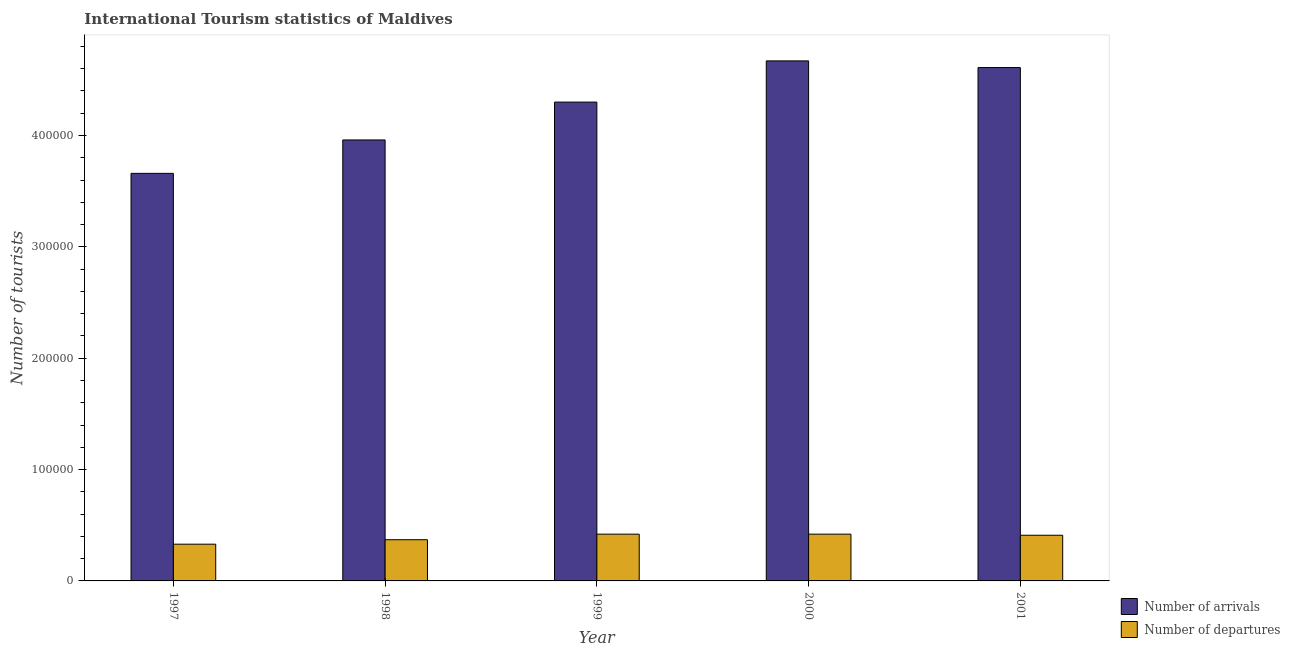How many groups of bars are there?
Offer a very short reply. 5. How many bars are there on the 4th tick from the left?
Give a very brief answer. 2. What is the label of the 2nd group of bars from the left?
Keep it short and to the point. 1998. In how many cases, is the number of bars for a given year not equal to the number of legend labels?
Your answer should be very brief. 0. What is the number of tourist departures in 1999?
Provide a succinct answer. 4.20e+04. Across all years, what is the maximum number of tourist departures?
Offer a terse response. 4.20e+04. Across all years, what is the minimum number of tourist arrivals?
Your response must be concise. 3.66e+05. In which year was the number of tourist departures maximum?
Make the answer very short. 1999. What is the total number of tourist arrivals in the graph?
Keep it short and to the point. 2.12e+06. What is the difference between the number of tourist arrivals in 1999 and that in 2001?
Provide a succinct answer. -3.10e+04. What is the difference between the number of tourist arrivals in 2001 and the number of tourist departures in 1999?
Provide a succinct answer. 3.10e+04. What is the average number of tourist departures per year?
Provide a succinct answer. 3.90e+04. What is the ratio of the number of tourist arrivals in 1999 to that in 2000?
Keep it short and to the point. 0.92. Is the number of tourist departures in 1997 less than that in 2000?
Offer a terse response. Yes. What is the difference between the highest and the lowest number of tourist departures?
Provide a succinct answer. 9000. In how many years, is the number of tourist departures greater than the average number of tourist departures taken over all years?
Your answer should be very brief. 3. What does the 1st bar from the left in 1997 represents?
Your response must be concise. Number of arrivals. What does the 1st bar from the right in 2001 represents?
Ensure brevity in your answer.  Number of departures. How many years are there in the graph?
Provide a short and direct response. 5. What is the difference between two consecutive major ticks on the Y-axis?
Keep it short and to the point. 1.00e+05. Are the values on the major ticks of Y-axis written in scientific E-notation?
Your response must be concise. No. Does the graph contain any zero values?
Provide a succinct answer. No. How many legend labels are there?
Offer a very short reply. 2. What is the title of the graph?
Your answer should be compact. International Tourism statistics of Maldives. Does "Boys" appear as one of the legend labels in the graph?
Ensure brevity in your answer.  No. What is the label or title of the Y-axis?
Keep it short and to the point. Number of tourists. What is the Number of tourists of Number of arrivals in 1997?
Your response must be concise. 3.66e+05. What is the Number of tourists in Number of departures in 1997?
Keep it short and to the point. 3.30e+04. What is the Number of tourists in Number of arrivals in 1998?
Make the answer very short. 3.96e+05. What is the Number of tourists of Number of departures in 1998?
Offer a terse response. 3.70e+04. What is the Number of tourists in Number of arrivals in 1999?
Give a very brief answer. 4.30e+05. What is the Number of tourists of Number of departures in 1999?
Your answer should be compact. 4.20e+04. What is the Number of tourists in Number of arrivals in 2000?
Ensure brevity in your answer.  4.67e+05. What is the Number of tourists of Number of departures in 2000?
Provide a short and direct response. 4.20e+04. What is the Number of tourists in Number of arrivals in 2001?
Your answer should be very brief. 4.61e+05. What is the Number of tourists of Number of departures in 2001?
Your response must be concise. 4.10e+04. Across all years, what is the maximum Number of tourists in Number of arrivals?
Provide a short and direct response. 4.67e+05. Across all years, what is the maximum Number of tourists of Number of departures?
Offer a very short reply. 4.20e+04. Across all years, what is the minimum Number of tourists in Number of arrivals?
Provide a short and direct response. 3.66e+05. Across all years, what is the minimum Number of tourists of Number of departures?
Provide a succinct answer. 3.30e+04. What is the total Number of tourists of Number of arrivals in the graph?
Offer a very short reply. 2.12e+06. What is the total Number of tourists of Number of departures in the graph?
Your answer should be very brief. 1.95e+05. What is the difference between the Number of tourists of Number of arrivals in 1997 and that in 1998?
Make the answer very short. -3.00e+04. What is the difference between the Number of tourists of Number of departures in 1997 and that in 1998?
Your response must be concise. -4000. What is the difference between the Number of tourists in Number of arrivals in 1997 and that in 1999?
Your answer should be compact. -6.40e+04. What is the difference between the Number of tourists in Number of departures in 1997 and that in 1999?
Provide a short and direct response. -9000. What is the difference between the Number of tourists of Number of arrivals in 1997 and that in 2000?
Your response must be concise. -1.01e+05. What is the difference between the Number of tourists of Number of departures in 1997 and that in 2000?
Provide a succinct answer. -9000. What is the difference between the Number of tourists in Number of arrivals in 1997 and that in 2001?
Provide a short and direct response. -9.50e+04. What is the difference between the Number of tourists in Number of departures in 1997 and that in 2001?
Your response must be concise. -8000. What is the difference between the Number of tourists of Number of arrivals in 1998 and that in 1999?
Your answer should be compact. -3.40e+04. What is the difference between the Number of tourists in Number of departures in 1998 and that in 1999?
Provide a short and direct response. -5000. What is the difference between the Number of tourists of Number of arrivals in 1998 and that in 2000?
Your response must be concise. -7.10e+04. What is the difference between the Number of tourists in Number of departures in 1998 and that in 2000?
Your answer should be very brief. -5000. What is the difference between the Number of tourists of Number of arrivals in 1998 and that in 2001?
Ensure brevity in your answer.  -6.50e+04. What is the difference between the Number of tourists of Number of departures in 1998 and that in 2001?
Keep it short and to the point. -4000. What is the difference between the Number of tourists in Number of arrivals in 1999 and that in 2000?
Your answer should be compact. -3.70e+04. What is the difference between the Number of tourists in Number of arrivals in 1999 and that in 2001?
Keep it short and to the point. -3.10e+04. What is the difference between the Number of tourists in Number of arrivals in 2000 and that in 2001?
Offer a terse response. 6000. What is the difference between the Number of tourists of Number of departures in 2000 and that in 2001?
Offer a very short reply. 1000. What is the difference between the Number of tourists of Number of arrivals in 1997 and the Number of tourists of Number of departures in 1998?
Give a very brief answer. 3.29e+05. What is the difference between the Number of tourists of Number of arrivals in 1997 and the Number of tourists of Number of departures in 1999?
Your answer should be very brief. 3.24e+05. What is the difference between the Number of tourists in Number of arrivals in 1997 and the Number of tourists in Number of departures in 2000?
Ensure brevity in your answer.  3.24e+05. What is the difference between the Number of tourists in Number of arrivals in 1997 and the Number of tourists in Number of departures in 2001?
Give a very brief answer. 3.25e+05. What is the difference between the Number of tourists of Number of arrivals in 1998 and the Number of tourists of Number of departures in 1999?
Make the answer very short. 3.54e+05. What is the difference between the Number of tourists of Number of arrivals in 1998 and the Number of tourists of Number of departures in 2000?
Your response must be concise. 3.54e+05. What is the difference between the Number of tourists of Number of arrivals in 1998 and the Number of tourists of Number of departures in 2001?
Ensure brevity in your answer.  3.55e+05. What is the difference between the Number of tourists in Number of arrivals in 1999 and the Number of tourists in Number of departures in 2000?
Provide a short and direct response. 3.88e+05. What is the difference between the Number of tourists in Number of arrivals in 1999 and the Number of tourists in Number of departures in 2001?
Provide a short and direct response. 3.89e+05. What is the difference between the Number of tourists of Number of arrivals in 2000 and the Number of tourists of Number of departures in 2001?
Keep it short and to the point. 4.26e+05. What is the average Number of tourists of Number of arrivals per year?
Make the answer very short. 4.24e+05. What is the average Number of tourists of Number of departures per year?
Give a very brief answer. 3.90e+04. In the year 1997, what is the difference between the Number of tourists in Number of arrivals and Number of tourists in Number of departures?
Ensure brevity in your answer.  3.33e+05. In the year 1998, what is the difference between the Number of tourists of Number of arrivals and Number of tourists of Number of departures?
Your answer should be very brief. 3.59e+05. In the year 1999, what is the difference between the Number of tourists in Number of arrivals and Number of tourists in Number of departures?
Give a very brief answer. 3.88e+05. In the year 2000, what is the difference between the Number of tourists of Number of arrivals and Number of tourists of Number of departures?
Your answer should be compact. 4.25e+05. In the year 2001, what is the difference between the Number of tourists of Number of arrivals and Number of tourists of Number of departures?
Provide a short and direct response. 4.20e+05. What is the ratio of the Number of tourists of Number of arrivals in 1997 to that in 1998?
Keep it short and to the point. 0.92. What is the ratio of the Number of tourists in Number of departures in 1997 to that in 1998?
Keep it short and to the point. 0.89. What is the ratio of the Number of tourists in Number of arrivals in 1997 to that in 1999?
Offer a very short reply. 0.85. What is the ratio of the Number of tourists of Number of departures in 1997 to that in 1999?
Your answer should be very brief. 0.79. What is the ratio of the Number of tourists in Number of arrivals in 1997 to that in 2000?
Ensure brevity in your answer.  0.78. What is the ratio of the Number of tourists of Number of departures in 1997 to that in 2000?
Provide a short and direct response. 0.79. What is the ratio of the Number of tourists in Number of arrivals in 1997 to that in 2001?
Provide a short and direct response. 0.79. What is the ratio of the Number of tourists of Number of departures in 1997 to that in 2001?
Your answer should be very brief. 0.8. What is the ratio of the Number of tourists of Number of arrivals in 1998 to that in 1999?
Offer a terse response. 0.92. What is the ratio of the Number of tourists in Number of departures in 1998 to that in 1999?
Keep it short and to the point. 0.88. What is the ratio of the Number of tourists of Number of arrivals in 1998 to that in 2000?
Offer a very short reply. 0.85. What is the ratio of the Number of tourists of Number of departures in 1998 to that in 2000?
Offer a very short reply. 0.88. What is the ratio of the Number of tourists of Number of arrivals in 1998 to that in 2001?
Provide a short and direct response. 0.86. What is the ratio of the Number of tourists in Number of departures in 1998 to that in 2001?
Give a very brief answer. 0.9. What is the ratio of the Number of tourists of Number of arrivals in 1999 to that in 2000?
Your answer should be very brief. 0.92. What is the ratio of the Number of tourists in Number of arrivals in 1999 to that in 2001?
Give a very brief answer. 0.93. What is the ratio of the Number of tourists of Number of departures in 1999 to that in 2001?
Offer a very short reply. 1.02. What is the ratio of the Number of tourists in Number of arrivals in 2000 to that in 2001?
Give a very brief answer. 1.01. What is the ratio of the Number of tourists of Number of departures in 2000 to that in 2001?
Make the answer very short. 1.02. What is the difference between the highest and the second highest Number of tourists in Number of arrivals?
Provide a short and direct response. 6000. What is the difference between the highest and the second highest Number of tourists in Number of departures?
Provide a succinct answer. 0. What is the difference between the highest and the lowest Number of tourists of Number of arrivals?
Offer a terse response. 1.01e+05. What is the difference between the highest and the lowest Number of tourists in Number of departures?
Give a very brief answer. 9000. 